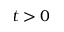<formula> <loc_0><loc_0><loc_500><loc_500>t > 0</formula> 